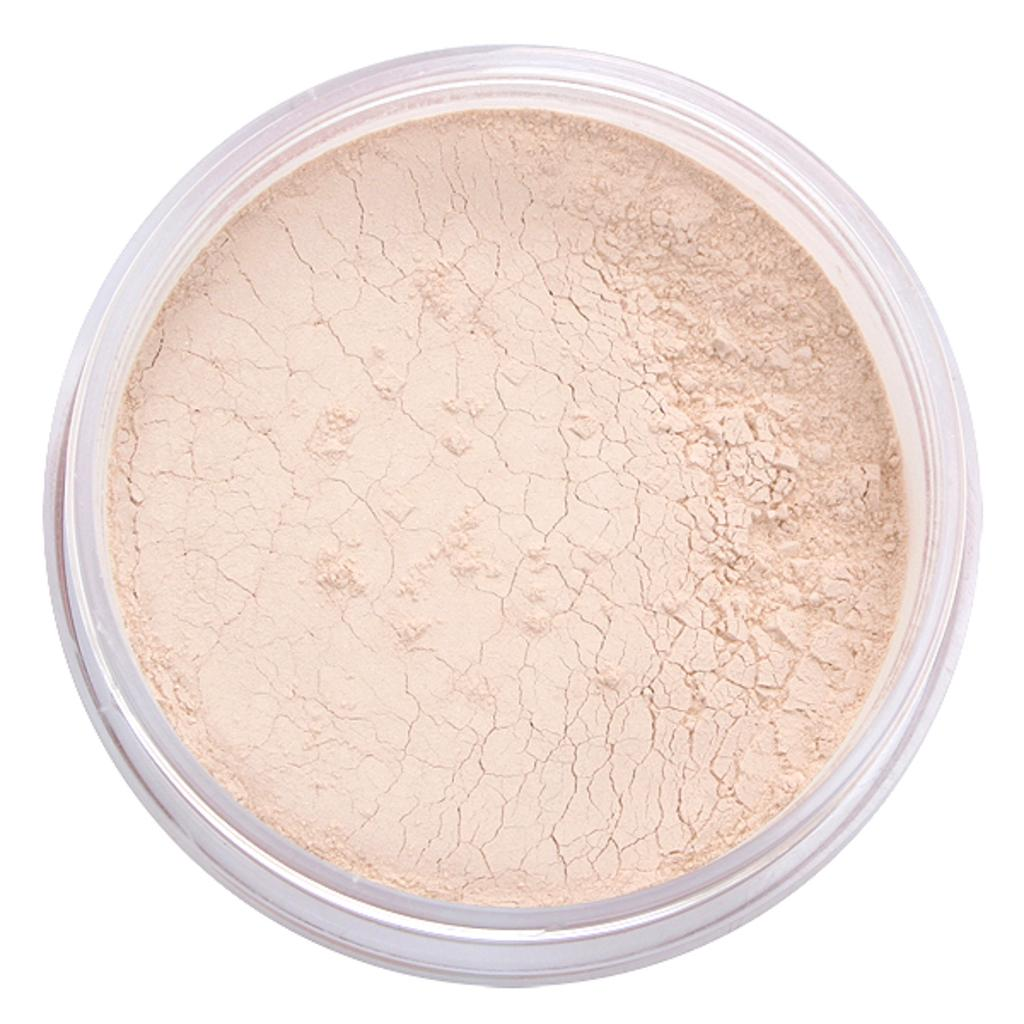What substance is visible in the image? There is powder in the image. Where is the powder stored in the image? The powder is in a plastic container. What type of clouds can be seen in the image? There are no clouds present in the image; it only features powder in a plastic container. How does the powder express anger in the image? The powder does not express anger in the image, as it is an inanimate substance. 